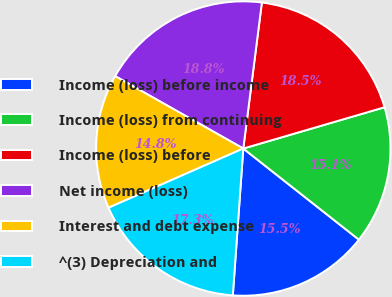Convert chart to OTSL. <chart><loc_0><loc_0><loc_500><loc_500><pie_chart><fcel>Income (loss) before income<fcel>Income (loss) from continuing<fcel>Income (loss) before<fcel>Net income (loss)<fcel>Interest and debt expense<fcel>^(3) Depreciation and<nl><fcel>15.51%<fcel>15.15%<fcel>18.46%<fcel>18.83%<fcel>14.78%<fcel>17.28%<nl></chart> 